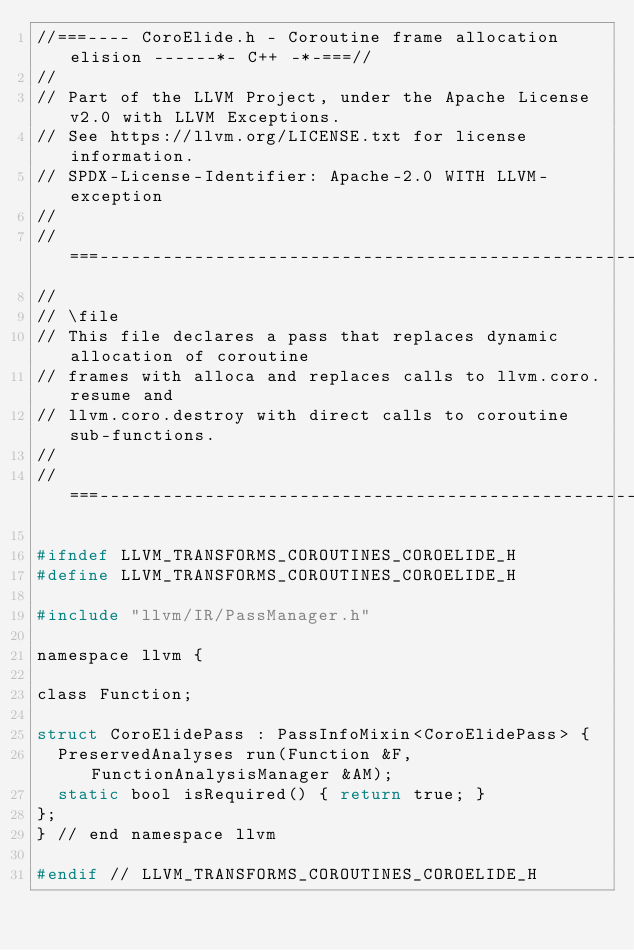Convert code to text. <code><loc_0><loc_0><loc_500><loc_500><_C_>//===---- CoroElide.h - Coroutine frame allocation elision ------*- C++ -*-===//
//
// Part of the LLVM Project, under the Apache License v2.0 with LLVM Exceptions.
// See https://llvm.org/LICENSE.txt for license information.
// SPDX-License-Identifier: Apache-2.0 WITH LLVM-exception
//
//===----------------------------------------------------------------------===//
//
// \file
// This file declares a pass that replaces dynamic allocation of coroutine
// frames with alloca and replaces calls to llvm.coro.resume and
// llvm.coro.destroy with direct calls to coroutine sub-functions.
//
//===----------------------------------------------------------------------===//

#ifndef LLVM_TRANSFORMS_COROUTINES_COROELIDE_H
#define LLVM_TRANSFORMS_COROUTINES_COROELIDE_H

#include "llvm/IR/PassManager.h"

namespace llvm {

class Function;

struct CoroElidePass : PassInfoMixin<CoroElidePass> {
  PreservedAnalyses run(Function &F, FunctionAnalysisManager &AM);
  static bool isRequired() { return true; }
};
} // end namespace llvm

#endif // LLVM_TRANSFORMS_COROUTINES_COROELIDE_H
</code> 